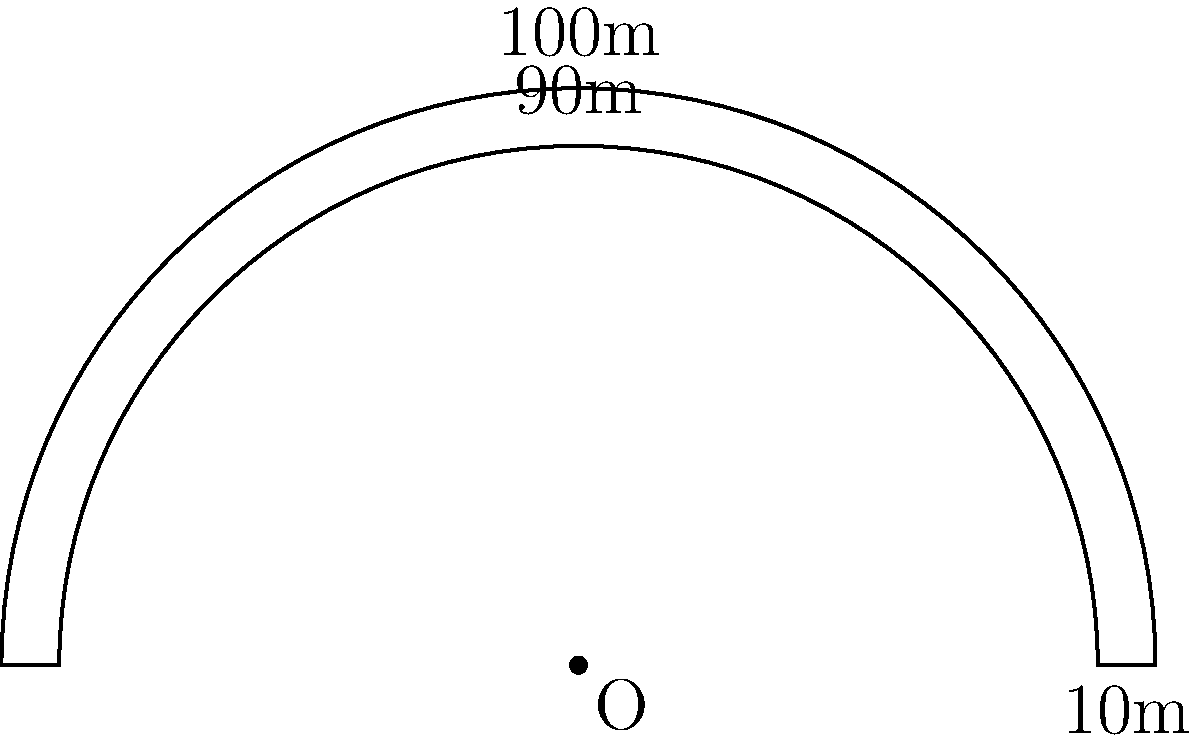A running track in a stadium has a semicircular shape. The outer edge of the track has a radius of 100 meters, while the inner edge has a radius of 90 meters. What is the total surface area of the track in square meters? To calculate the surface area of the curved running track, we need to follow these steps:

1. Calculate the area of the outer semicircle:
   $$A_{outer} = \frac{1}{2} \pi r^2 = \frac{1}{2} \pi (100)^2 = 15,707.96 \text{ m}^2$$

2. Calculate the area of the inner semicircle:
   $$A_{inner} = \frac{1}{2} \pi r^2 = \frac{1}{2} \pi (90)^2 = 12,723.45 \text{ m}^2$$

3. Calculate the area of the track by subtracting the inner area from the outer area:
   $$A_{track} = A_{outer} - A_{inner} = 15,707.96 - 12,723.45 = 2,984.51 \text{ m}^2$$

Therefore, the total surface area of the track is approximately 2,984.51 square meters.
Answer: 2,984.51 m² 